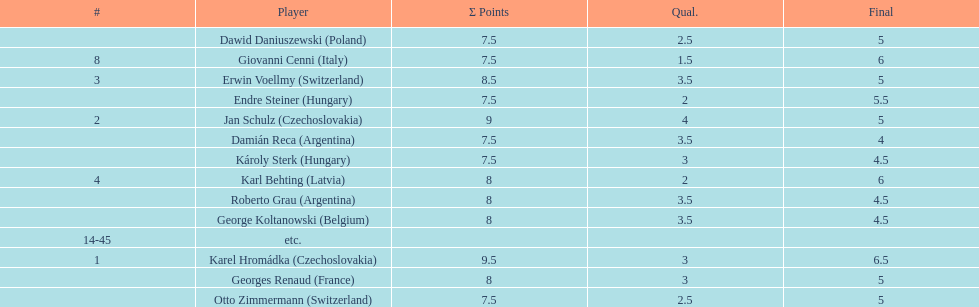How many players had a 8 points? 4. 